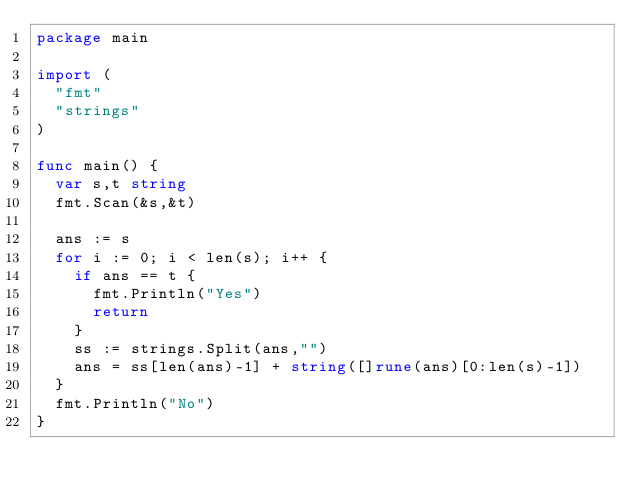Convert code to text. <code><loc_0><loc_0><loc_500><loc_500><_Go_>package main

import (
	"fmt"
	"strings"
)

func main() {
	var s,t string
	fmt.Scan(&s,&t)

	ans := s
	for i := 0; i < len(s); i++ {
		if ans == t {
			fmt.Println("Yes")
			return
		}
		ss := strings.Split(ans,"")
		ans = ss[len(ans)-1] + string([]rune(ans)[0:len(s)-1])
	}
	fmt.Println("No")
}</code> 